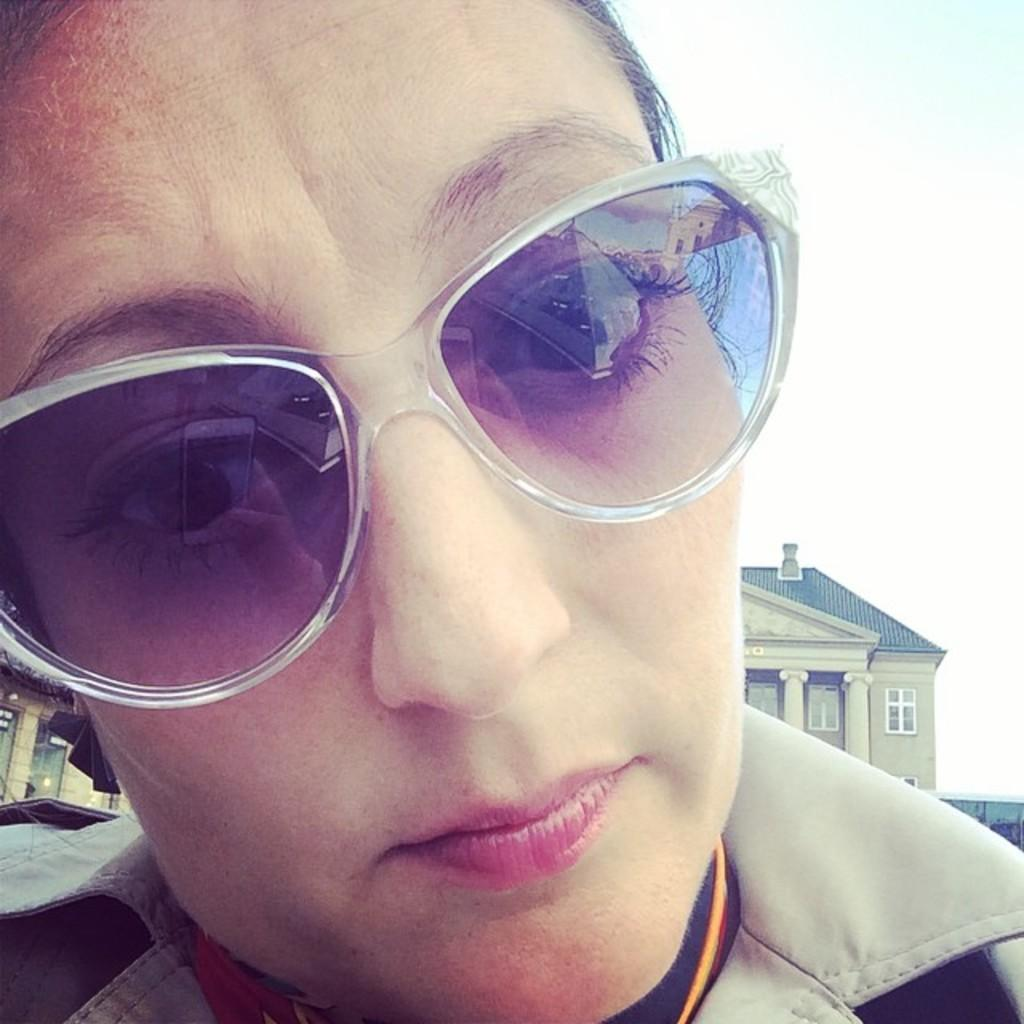Who is present in the image? There is a woman in the picture. What is the woman wearing in the image? The woman is wearing sunglasses. What can be seen in the background of the image? There are buildings in the background of the image. How would you describe the weather in the image? The sky is cloudy in the image. What type of creature is the woman attempting to capture in the image? There is no creature present in the image, and the woman is not attempting to capture anything. 